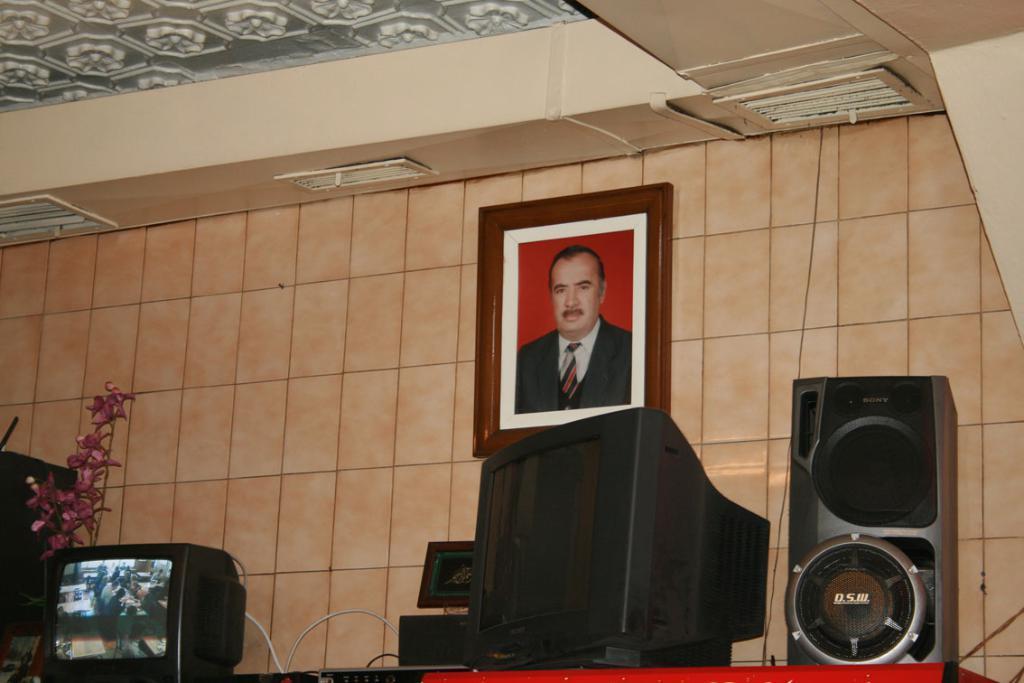Could you give a brief overview of what you see in this image? In this image I can see a television, a monitor, a speaker, a plant and few other things. I can also see a frame on the wall and I can see this frame contains the picture of a man. I can also see he is wearing formal dress. 